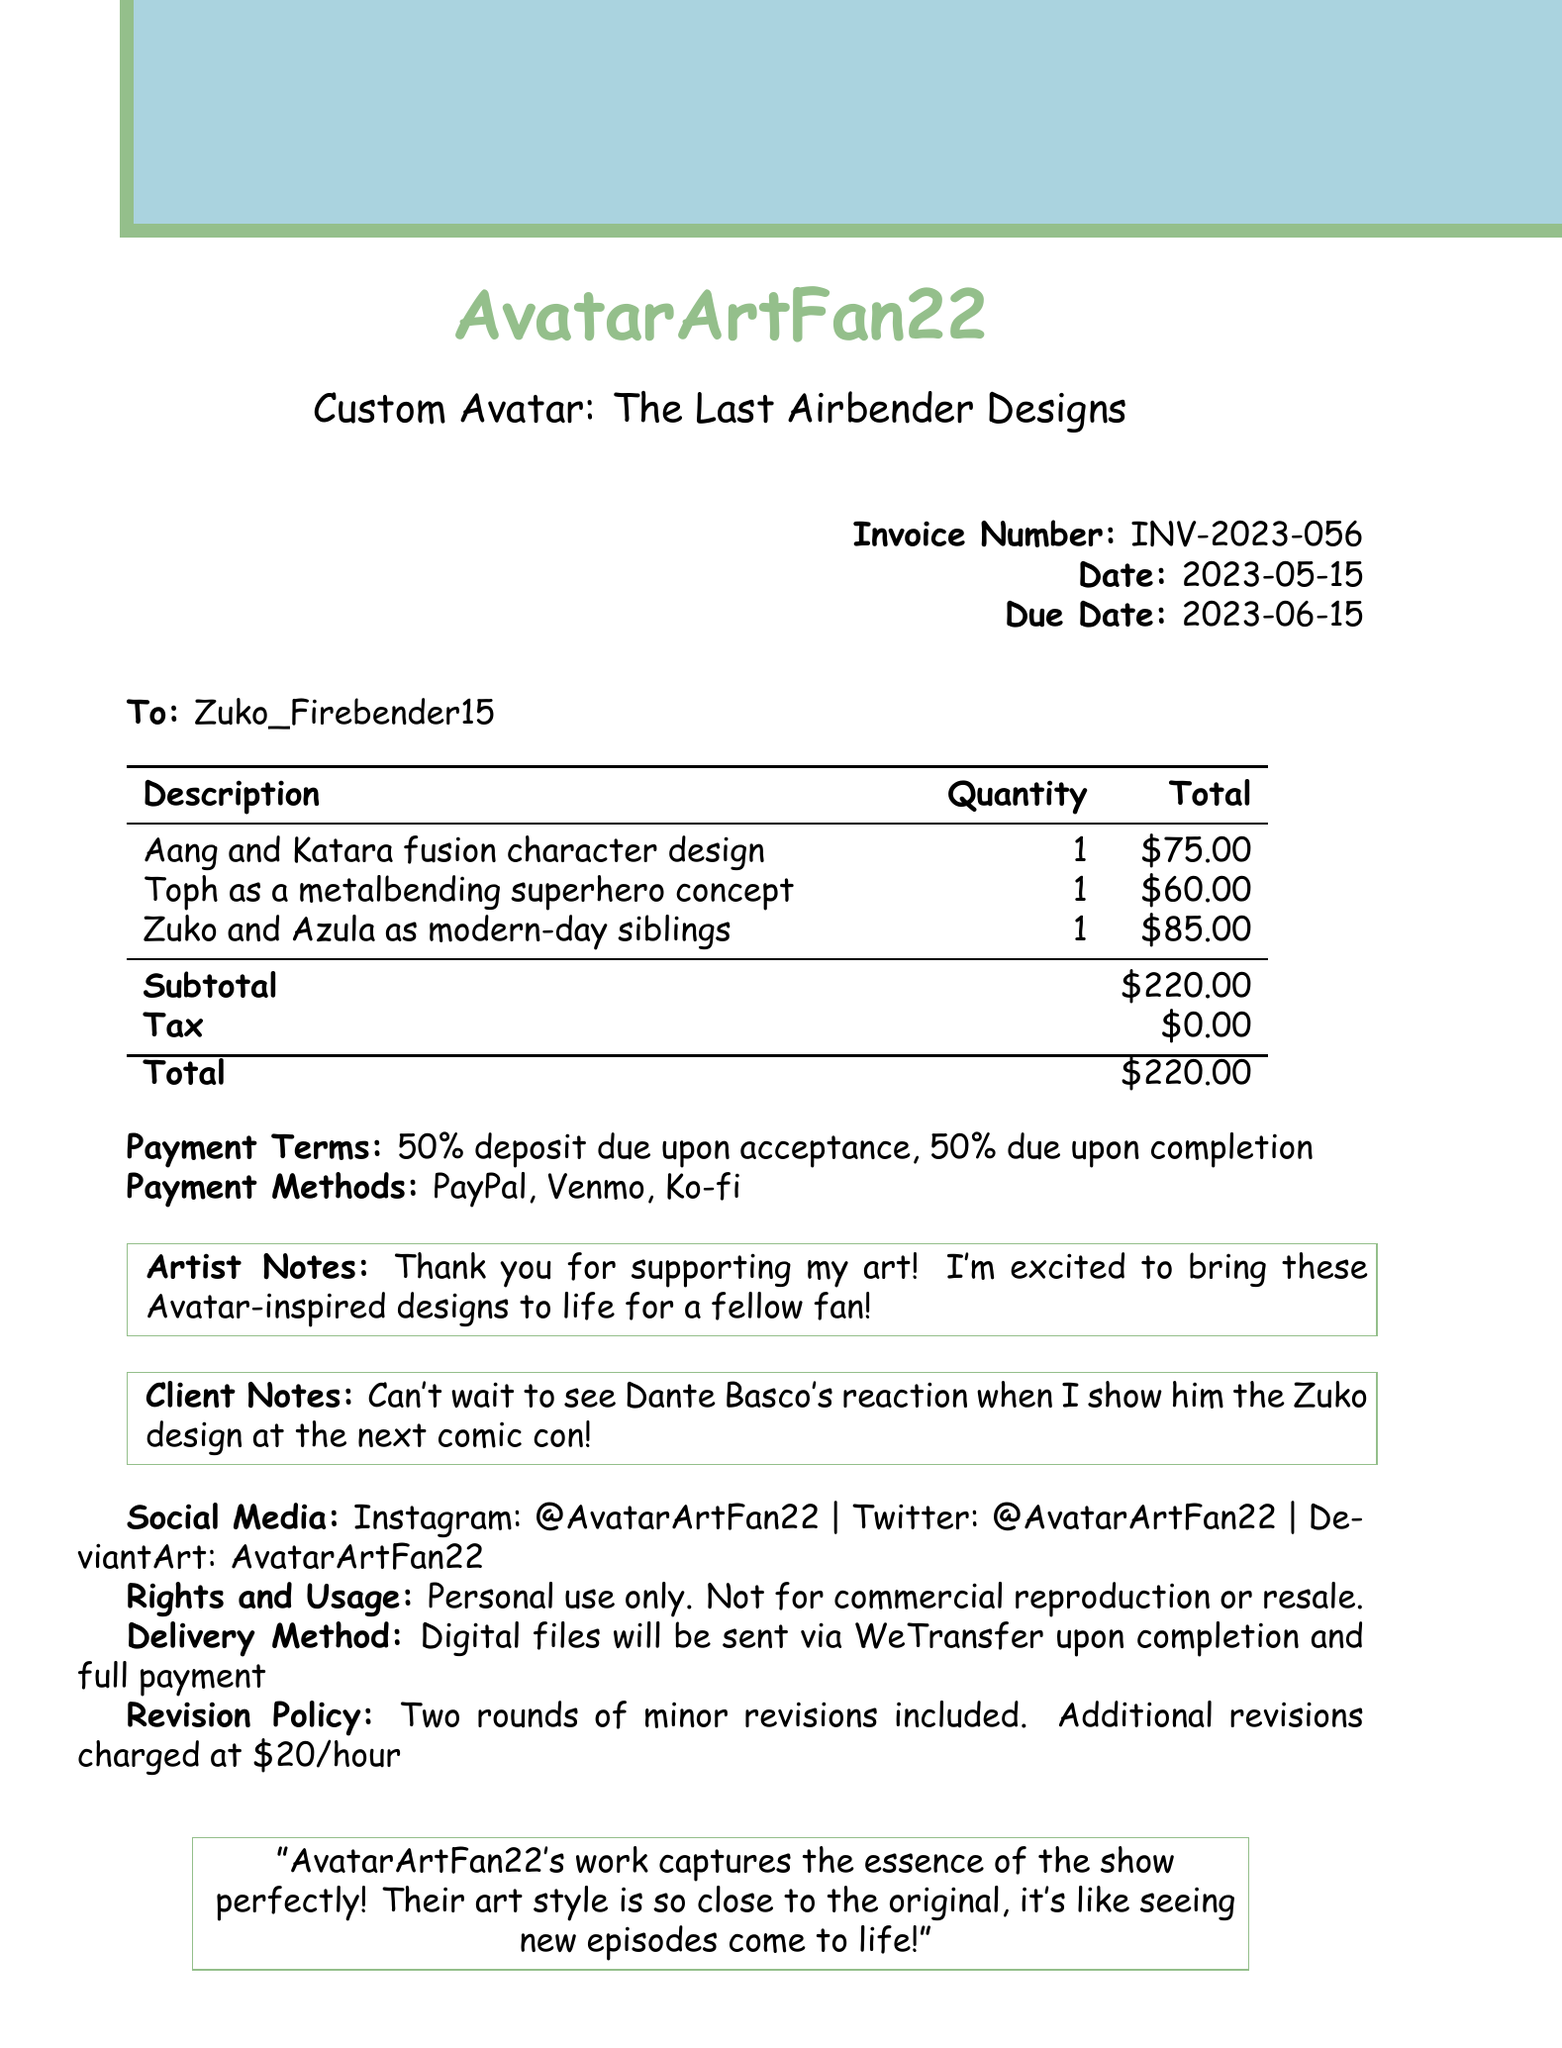What is the artist's name? The artist's name is provided at the top of the invoice.
Answer: AvatarArtFan22 What is the total amount due? The total amount reflects the sum of the line items before tax.
Answer: $220.00 When is the due date for the invoice? The due date is explicitly stated in the document.
Answer: 2023-06-15 How many character designs are included in the invoice? Each line item represents a different character design, and there are three listed.
Answer: 3 What payment method is NOT mentioned in the document? The document lists specific payment methods, and any unlisted method is not mentioned.
Answer: Cash What is the payment term for the deposit? The payment terms detail the deposit requirement clearly.
Answer: 50% deposit due upon acceptance What character concept features Toph? The description specifically mentions a character concept featuring Toph.
Answer: Toph as a metalbending superhero concept Is tax included in the total amount? The document explicitly states the tax amount listed.
Answer: No How many rounds of revisions are included? The revision policy provides information on the included revisions.
Answer: Two 